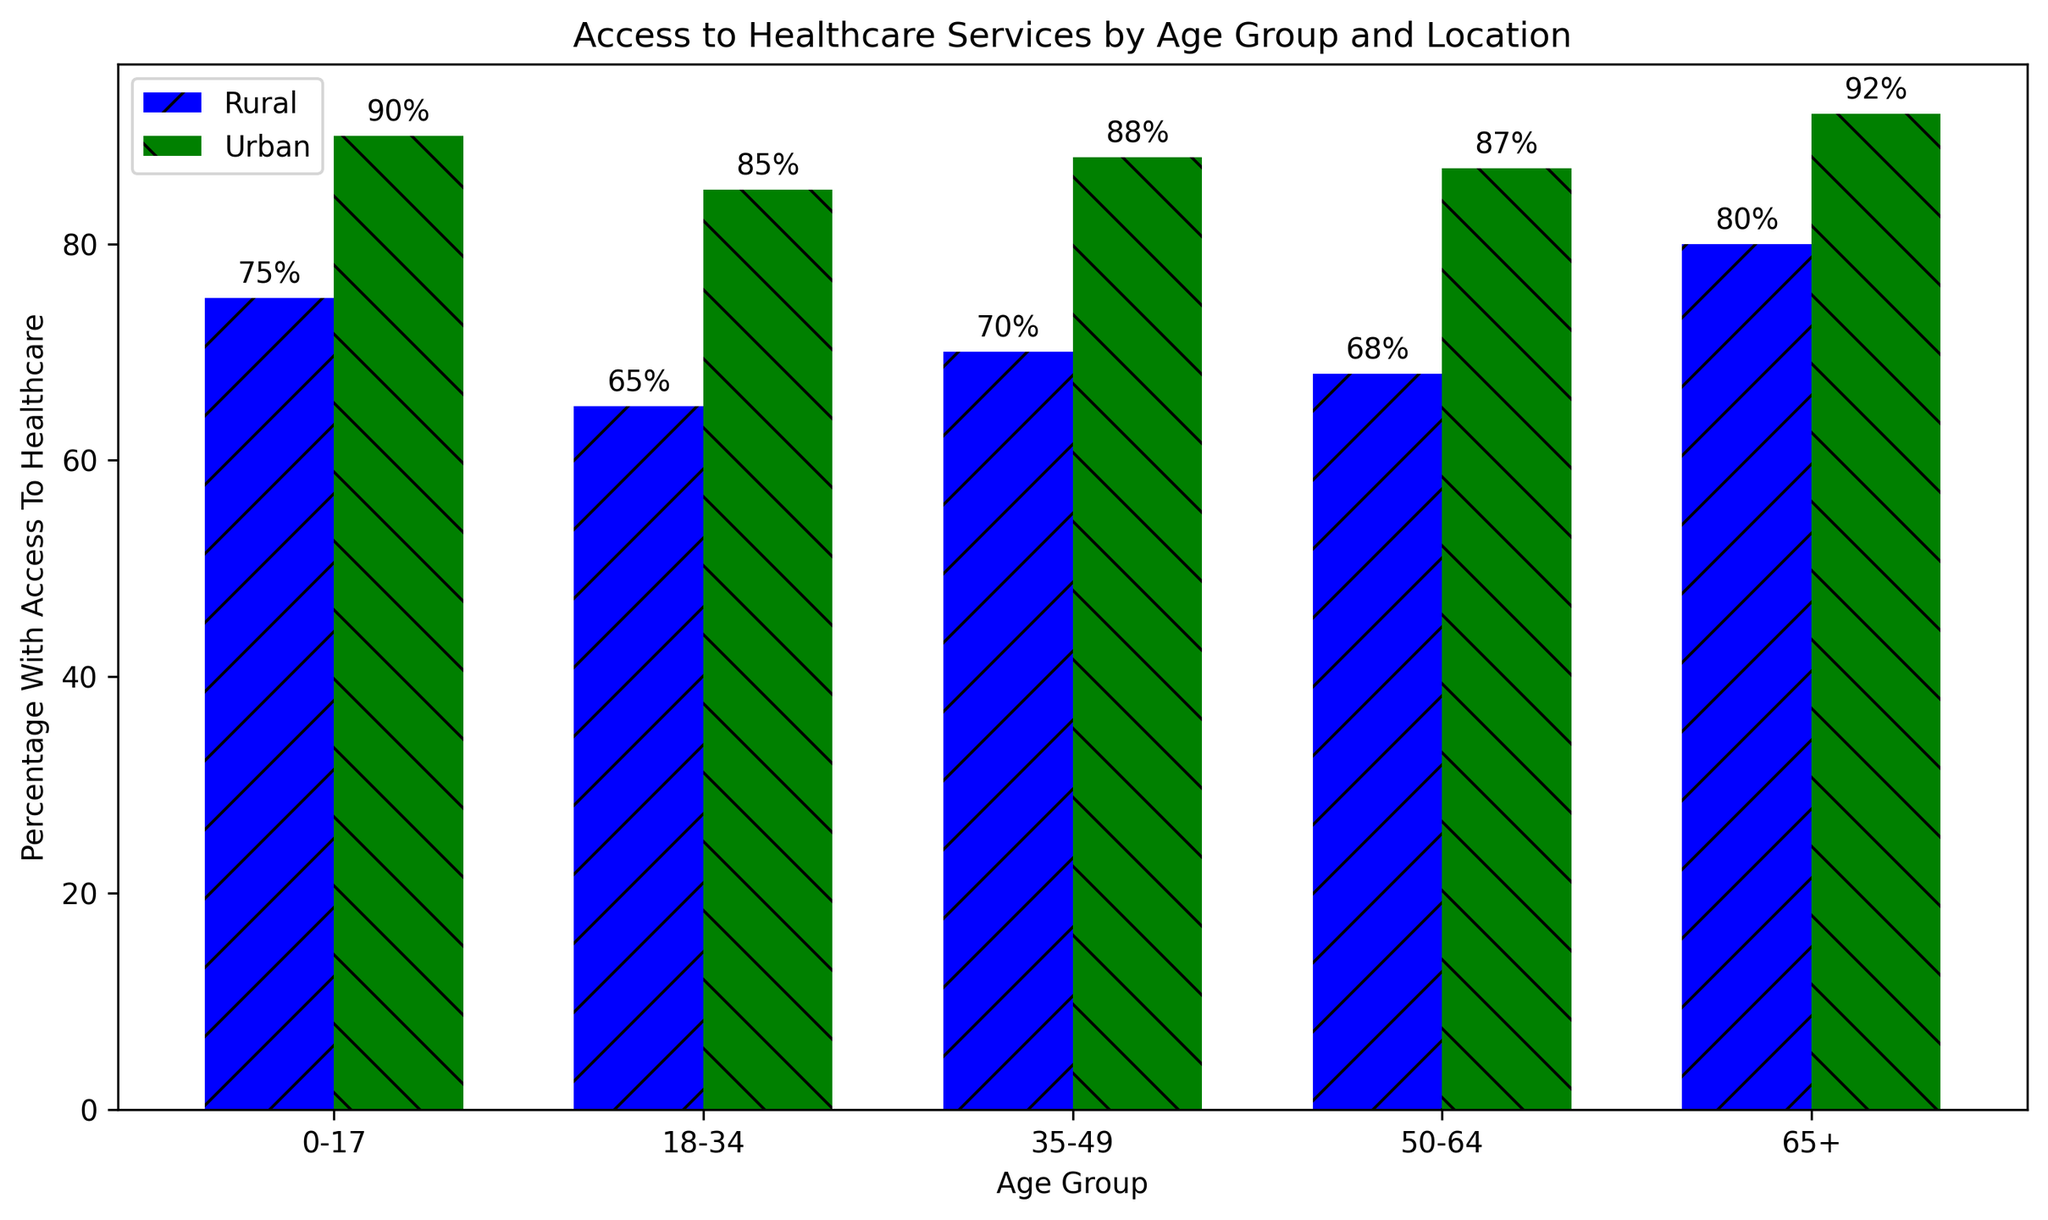What is the percentage difference in access to healthcare services for the 18-34 age group between rural and urban areas? The percentage of 18-34 age group with access in rural areas is 65%, and in urban areas is 85%. The difference is 85% - 65% = 20%.
Answer: 20% Which age group has the highest access to healthcare services in rural areas? Among rural age groups, the 0-17 group has the highest percentage at 75%.
Answer: 0-17 How much higher is the access to healthcare services for the 50-64 age group in urban areas compared to rural areas? The percentage of 50-64 age group with access in urban areas is 87%, while in rural areas, it is 68%. Therefore, the access is 87% - 68% = 19% higher in urban areas.
Answer: 19% What is the average percentage of access to healthcare services across all age groups in urban areas? The urban percentages are 90%, 85%, 88%, 87%, and 92%. The average is (90 + 85 + 88 + 87 + 92) / 5 = 88.4%.
Answer: 88.4% Which age group shows the smallest gap in access to healthcare services between rural and urban areas? Examining all groups, the 0-17 age group has the smallest gap with 90% (urban) - 75% (rural) = 15%.
Answer: 0-17 How much higher is the access to healthcare services in urban areas compared to rural areas for the 65+ age group? The percentage of 65+ with access in urban areas is 92%, while in rural areas, it is 80%. Therefore, the access is 92% - 80% = 12% higher in urban areas.
Answer: 12% What is the total percentage of access to healthcare services for rural areas in all age groups combined? The rural percentages are 75%, 65%, 70%, 68%, and 80%. The total is 75 + 65 + 70 + 68 + 80 = 358%.
Answer: 358% Which location, rural or urban, shows a more consistent access to healthcare services across all age groups based on percentage differences? Urban percentages are 90%, 85%, 88%, 87%, and 92% with a range of 92 - 85 = 7%. Rural percentages are 75%, 65%, 70%, 68%, and 80% with a range of 80 - 65 = 15%. Urban areas show more consistency.
Answer: Urban What is the average percentage difference in access to healthcare services between rural and urban areas across all age groups? The differences for each group are: 0-17 (15%), 18-34 (20%), 35-49 (18%), 50-64 (19%), and 65+ (12%). The average difference is (15 + 20 + 18 + 19 + 12) / 5 = 16.8%.
Answer: 16.8% How does access to healthcare services change across age groups in rural areas? In rural areas, the percentages are: 0-17 (75%), 18-34 (65%), 35-49 (70%), 50-64 (68%), and 65+ (80%). Access decreases from 0-17 to 18-34, rises in 35-49, slightly decreases in 50-64, and rises again in 65+.
Answer: Decreases, rises, decreases, rises 